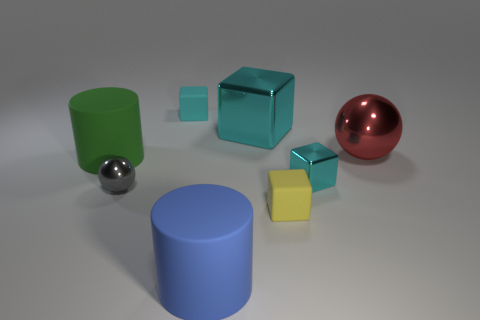How many cyan blocks must be subtracted to get 1 cyan blocks? 2 Subtract all purple cylinders. How many cyan cubes are left? 3 Subtract all yellow blocks. How many blocks are left? 3 Subtract all large cyan cubes. How many cubes are left? 3 Add 1 purple balls. How many objects exist? 9 Subtract all brown blocks. Subtract all red spheres. How many blocks are left? 4 Subtract all cylinders. How many objects are left? 6 Subtract all cyan things. Subtract all gray matte balls. How many objects are left? 5 Add 5 tiny cyan matte objects. How many tiny cyan matte objects are left? 6 Add 5 big cylinders. How many big cylinders exist? 7 